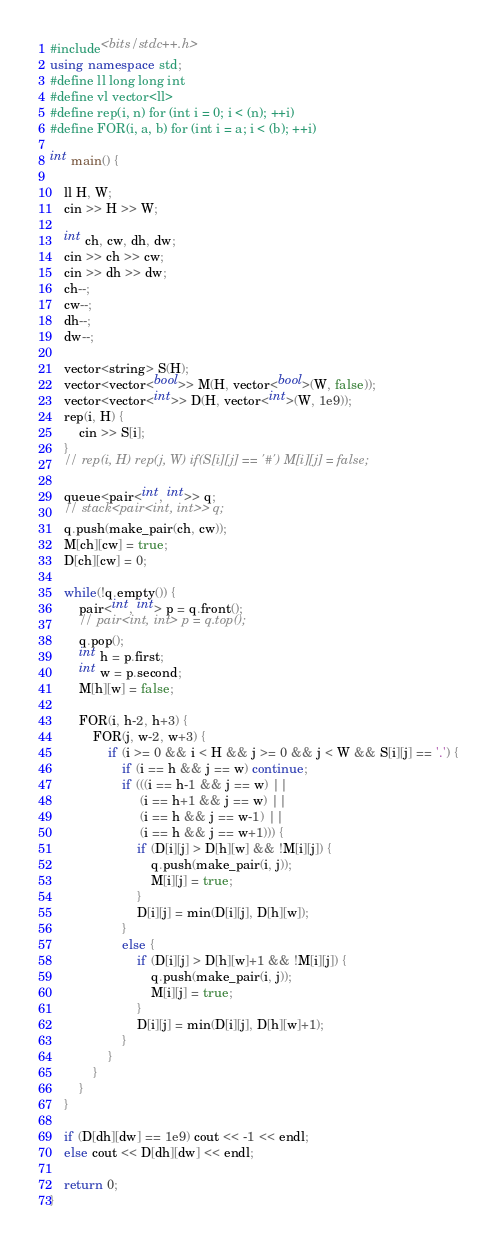<code> <loc_0><loc_0><loc_500><loc_500><_C++_>#include<bits/stdc++.h>
using namespace std;
#define ll long long int
#define vl vector<ll>
#define rep(i, n) for (int i = 0; i < (n); ++i)
#define FOR(i, a, b) for (int i = a; i < (b); ++i)

int main() {

    ll H, W;
    cin >> H >> W;

    int ch, cw, dh, dw;
    cin >> ch >> cw;
    cin >> dh >> dw;
    ch--;
    cw--;
    dh--;
    dw--;

    vector<string> S(H);
    vector<vector<bool>> M(H, vector<bool>(W, false));
    vector<vector<int>> D(H, vector<int>(W, 1e9));
    rep(i, H) {
        cin >> S[i];
    }
    // rep(i, H) rep(j, W) if(S[i][j] == '#') M[i][j] = false;

    queue<pair<int, int>> q;
    // stack<pair<int, int>> q;
    q.push(make_pair(ch, cw));
    M[ch][cw] = true;
    D[ch][cw] = 0;

    while(!q.empty()) {
        pair<int, int> p = q.front();
        // pair<int, int> p = q.top();
        q.pop();
        int h = p.first;
        int w = p.second;
        M[h][w] = false;

        FOR(i, h-2, h+3) {
            FOR(j, w-2, w+3) {
                if (i >= 0 && i < H && j >= 0 && j < W && S[i][j] == '.') {
                    if (i == h && j == w) continue;
                    if (((i == h-1 && j == w) ||
                         (i == h+1 && j == w) ||
                         (i == h && j == w-1) ||
                         (i == h && j == w+1))) {
                        if (D[i][j] > D[h][w] && !M[i][j]) {
                            q.push(make_pair(i, j));
                            M[i][j] = true;
                        }
                        D[i][j] = min(D[i][j], D[h][w]);
                    }
                    else {
                        if (D[i][j] > D[h][w]+1 && !M[i][j]) {
                            q.push(make_pair(i, j));
                            M[i][j] = true;
                        }
                        D[i][j] = min(D[i][j], D[h][w]+1);
                    }
                }
            }
        }
    }

    if (D[dh][dw] == 1e9) cout << -1 << endl;
    else cout << D[dh][dw] << endl;

    return 0;
}
</code> 